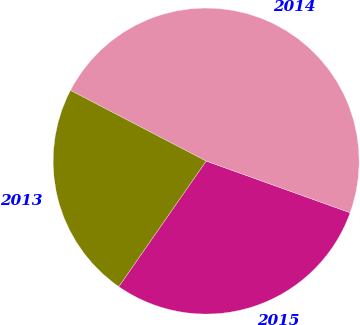Convert chart to OTSL. <chart><loc_0><loc_0><loc_500><loc_500><pie_chart><fcel>2015<fcel>2014<fcel>2013<nl><fcel>29.19%<fcel>47.85%<fcel>22.97%<nl></chart> 